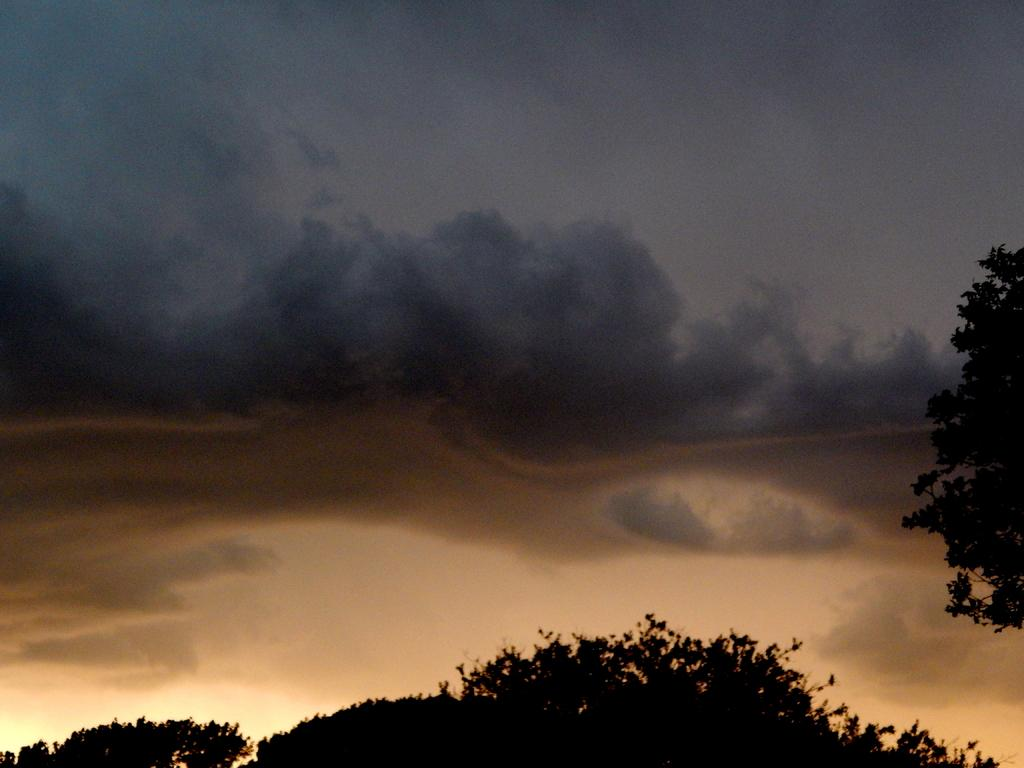What type of vegetation is present at the bottom of the image? There are trees at the bottom side of the image. Can you describe the tree on the right side of the image? There is another tree on the right side of the image. What can be seen in the background of the image? The sky is visible in the background of the image. What does the mother need to do in the image? There is no mother present in the image, so it is not possible to determine what she might need to do. 